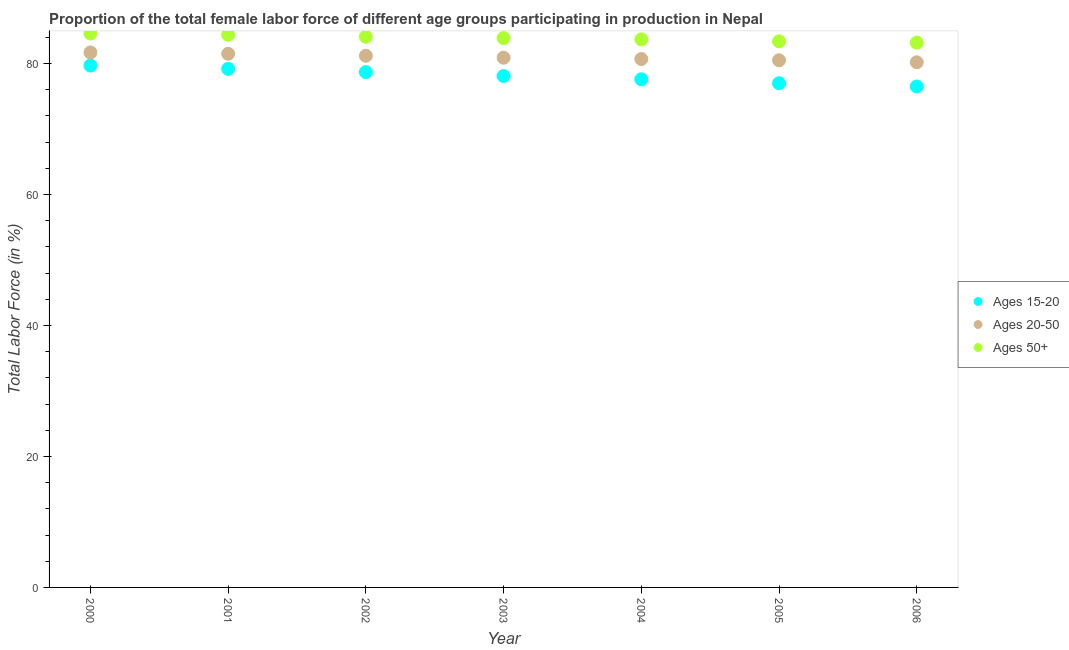Is the number of dotlines equal to the number of legend labels?
Your response must be concise. Yes. What is the percentage of female labor force above age 50 in 2004?
Provide a short and direct response. 83.7. Across all years, what is the maximum percentage of female labor force within the age group 20-50?
Give a very brief answer. 81.7. Across all years, what is the minimum percentage of female labor force within the age group 20-50?
Offer a very short reply. 80.2. In which year was the percentage of female labor force within the age group 15-20 maximum?
Your response must be concise. 2000. What is the total percentage of female labor force within the age group 15-20 in the graph?
Your answer should be compact. 546.8. What is the difference between the percentage of female labor force within the age group 15-20 in 2001 and the percentage of female labor force above age 50 in 2005?
Provide a short and direct response. -4.2. What is the average percentage of female labor force above age 50 per year?
Your answer should be compact. 83.9. In the year 2006, what is the difference between the percentage of female labor force within the age group 15-20 and percentage of female labor force within the age group 20-50?
Your answer should be compact. -3.7. What is the ratio of the percentage of female labor force within the age group 15-20 in 2003 to that in 2006?
Ensure brevity in your answer.  1.02. Is the percentage of female labor force above age 50 in 2001 less than that in 2004?
Provide a short and direct response. No. Is the difference between the percentage of female labor force within the age group 15-20 in 2004 and 2006 greater than the difference between the percentage of female labor force above age 50 in 2004 and 2006?
Provide a succinct answer. Yes. What is the difference between the highest and the second highest percentage of female labor force above age 50?
Your answer should be compact. 0.2. In how many years, is the percentage of female labor force within the age group 15-20 greater than the average percentage of female labor force within the age group 15-20 taken over all years?
Offer a very short reply. 3. Is the sum of the percentage of female labor force above age 50 in 2001 and 2004 greater than the maximum percentage of female labor force within the age group 20-50 across all years?
Provide a short and direct response. Yes. Is it the case that in every year, the sum of the percentage of female labor force within the age group 15-20 and percentage of female labor force within the age group 20-50 is greater than the percentage of female labor force above age 50?
Your response must be concise. Yes. Does the percentage of female labor force above age 50 monotonically increase over the years?
Make the answer very short. No. Is the percentage of female labor force within the age group 15-20 strictly greater than the percentage of female labor force above age 50 over the years?
Ensure brevity in your answer.  No. Is the percentage of female labor force above age 50 strictly less than the percentage of female labor force within the age group 20-50 over the years?
Make the answer very short. No. How many years are there in the graph?
Ensure brevity in your answer.  7. What is the difference between two consecutive major ticks on the Y-axis?
Offer a very short reply. 20. Are the values on the major ticks of Y-axis written in scientific E-notation?
Offer a terse response. No. Does the graph contain any zero values?
Give a very brief answer. No. Does the graph contain grids?
Make the answer very short. No. Where does the legend appear in the graph?
Make the answer very short. Center right. How many legend labels are there?
Keep it short and to the point. 3. How are the legend labels stacked?
Your answer should be very brief. Vertical. What is the title of the graph?
Keep it short and to the point. Proportion of the total female labor force of different age groups participating in production in Nepal. What is the label or title of the X-axis?
Your response must be concise. Year. What is the Total Labor Force (in %) of Ages 15-20 in 2000?
Make the answer very short. 79.7. What is the Total Labor Force (in %) of Ages 20-50 in 2000?
Provide a succinct answer. 81.7. What is the Total Labor Force (in %) of Ages 50+ in 2000?
Your answer should be compact. 84.6. What is the Total Labor Force (in %) of Ages 15-20 in 2001?
Offer a very short reply. 79.2. What is the Total Labor Force (in %) in Ages 20-50 in 2001?
Provide a succinct answer. 81.5. What is the Total Labor Force (in %) of Ages 50+ in 2001?
Your response must be concise. 84.4. What is the Total Labor Force (in %) of Ages 15-20 in 2002?
Your answer should be compact. 78.7. What is the Total Labor Force (in %) in Ages 20-50 in 2002?
Offer a terse response. 81.2. What is the Total Labor Force (in %) of Ages 50+ in 2002?
Make the answer very short. 84.1. What is the Total Labor Force (in %) of Ages 15-20 in 2003?
Provide a short and direct response. 78.1. What is the Total Labor Force (in %) in Ages 20-50 in 2003?
Provide a short and direct response. 80.9. What is the Total Labor Force (in %) of Ages 50+ in 2003?
Provide a succinct answer. 83.9. What is the Total Labor Force (in %) of Ages 15-20 in 2004?
Keep it short and to the point. 77.6. What is the Total Labor Force (in %) of Ages 20-50 in 2004?
Ensure brevity in your answer.  80.7. What is the Total Labor Force (in %) of Ages 50+ in 2004?
Give a very brief answer. 83.7. What is the Total Labor Force (in %) in Ages 20-50 in 2005?
Make the answer very short. 80.5. What is the Total Labor Force (in %) of Ages 50+ in 2005?
Your response must be concise. 83.4. What is the Total Labor Force (in %) in Ages 15-20 in 2006?
Your response must be concise. 76.5. What is the Total Labor Force (in %) in Ages 20-50 in 2006?
Your answer should be very brief. 80.2. What is the Total Labor Force (in %) of Ages 50+ in 2006?
Your answer should be very brief. 83.2. Across all years, what is the maximum Total Labor Force (in %) in Ages 15-20?
Your answer should be very brief. 79.7. Across all years, what is the maximum Total Labor Force (in %) of Ages 20-50?
Keep it short and to the point. 81.7. Across all years, what is the maximum Total Labor Force (in %) in Ages 50+?
Your response must be concise. 84.6. Across all years, what is the minimum Total Labor Force (in %) in Ages 15-20?
Offer a terse response. 76.5. Across all years, what is the minimum Total Labor Force (in %) in Ages 20-50?
Your answer should be very brief. 80.2. Across all years, what is the minimum Total Labor Force (in %) of Ages 50+?
Offer a very short reply. 83.2. What is the total Total Labor Force (in %) in Ages 15-20 in the graph?
Your answer should be very brief. 546.8. What is the total Total Labor Force (in %) of Ages 20-50 in the graph?
Provide a succinct answer. 566.7. What is the total Total Labor Force (in %) of Ages 50+ in the graph?
Keep it short and to the point. 587.3. What is the difference between the Total Labor Force (in %) in Ages 20-50 in 2000 and that in 2002?
Your answer should be very brief. 0.5. What is the difference between the Total Labor Force (in %) of Ages 50+ in 2000 and that in 2002?
Make the answer very short. 0.5. What is the difference between the Total Labor Force (in %) of Ages 15-20 in 2000 and that in 2003?
Your response must be concise. 1.6. What is the difference between the Total Labor Force (in %) of Ages 50+ in 2000 and that in 2003?
Your answer should be very brief. 0.7. What is the difference between the Total Labor Force (in %) in Ages 15-20 in 2000 and that in 2004?
Offer a terse response. 2.1. What is the difference between the Total Labor Force (in %) of Ages 20-50 in 2000 and that in 2004?
Provide a short and direct response. 1. What is the difference between the Total Labor Force (in %) in Ages 50+ in 2000 and that in 2004?
Keep it short and to the point. 0.9. What is the difference between the Total Labor Force (in %) of Ages 20-50 in 2000 and that in 2005?
Your answer should be very brief. 1.2. What is the difference between the Total Labor Force (in %) of Ages 15-20 in 2000 and that in 2006?
Keep it short and to the point. 3.2. What is the difference between the Total Labor Force (in %) of Ages 15-20 in 2001 and that in 2002?
Your response must be concise. 0.5. What is the difference between the Total Labor Force (in %) of Ages 50+ in 2001 and that in 2002?
Offer a very short reply. 0.3. What is the difference between the Total Labor Force (in %) in Ages 15-20 in 2001 and that in 2003?
Ensure brevity in your answer.  1.1. What is the difference between the Total Labor Force (in %) of Ages 50+ in 2001 and that in 2004?
Keep it short and to the point. 0.7. What is the difference between the Total Labor Force (in %) in Ages 20-50 in 2001 and that in 2005?
Make the answer very short. 1. What is the difference between the Total Labor Force (in %) of Ages 15-20 in 2001 and that in 2006?
Offer a very short reply. 2.7. What is the difference between the Total Labor Force (in %) of Ages 20-50 in 2001 and that in 2006?
Offer a very short reply. 1.3. What is the difference between the Total Labor Force (in %) of Ages 50+ in 2001 and that in 2006?
Give a very brief answer. 1.2. What is the difference between the Total Labor Force (in %) in Ages 20-50 in 2002 and that in 2005?
Your answer should be very brief. 0.7. What is the difference between the Total Labor Force (in %) of Ages 15-20 in 2002 and that in 2006?
Your response must be concise. 2.2. What is the difference between the Total Labor Force (in %) in Ages 20-50 in 2002 and that in 2006?
Keep it short and to the point. 1. What is the difference between the Total Labor Force (in %) in Ages 15-20 in 2003 and that in 2004?
Ensure brevity in your answer.  0.5. What is the difference between the Total Labor Force (in %) in Ages 20-50 in 2003 and that in 2004?
Provide a succinct answer. 0.2. What is the difference between the Total Labor Force (in %) in Ages 15-20 in 2003 and that in 2005?
Keep it short and to the point. 1.1. What is the difference between the Total Labor Force (in %) in Ages 15-20 in 2003 and that in 2006?
Your answer should be very brief. 1.6. What is the difference between the Total Labor Force (in %) in Ages 20-50 in 2003 and that in 2006?
Your answer should be compact. 0.7. What is the difference between the Total Labor Force (in %) of Ages 50+ in 2003 and that in 2006?
Provide a short and direct response. 0.7. What is the difference between the Total Labor Force (in %) of Ages 20-50 in 2004 and that in 2005?
Provide a short and direct response. 0.2. What is the difference between the Total Labor Force (in %) of Ages 15-20 in 2004 and that in 2006?
Your answer should be very brief. 1.1. What is the difference between the Total Labor Force (in %) in Ages 50+ in 2004 and that in 2006?
Ensure brevity in your answer.  0.5. What is the difference between the Total Labor Force (in %) of Ages 15-20 in 2005 and that in 2006?
Your response must be concise. 0.5. What is the difference between the Total Labor Force (in %) of Ages 50+ in 2005 and that in 2006?
Your answer should be very brief. 0.2. What is the difference between the Total Labor Force (in %) of Ages 15-20 in 2000 and the Total Labor Force (in %) of Ages 50+ in 2002?
Ensure brevity in your answer.  -4.4. What is the difference between the Total Labor Force (in %) in Ages 20-50 in 2000 and the Total Labor Force (in %) in Ages 50+ in 2002?
Your answer should be compact. -2.4. What is the difference between the Total Labor Force (in %) in Ages 15-20 in 2000 and the Total Labor Force (in %) in Ages 20-50 in 2003?
Make the answer very short. -1.2. What is the difference between the Total Labor Force (in %) of Ages 15-20 in 2000 and the Total Labor Force (in %) of Ages 50+ in 2003?
Give a very brief answer. -4.2. What is the difference between the Total Labor Force (in %) in Ages 20-50 in 2000 and the Total Labor Force (in %) in Ages 50+ in 2003?
Give a very brief answer. -2.2. What is the difference between the Total Labor Force (in %) in Ages 15-20 in 2000 and the Total Labor Force (in %) in Ages 20-50 in 2004?
Ensure brevity in your answer.  -1. What is the difference between the Total Labor Force (in %) in Ages 15-20 in 2000 and the Total Labor Force (in %) in Ages 20-50 in 2005?
Make the answer very short. -0.8. What is the difference between the Total Labor Force (in %) in Ages 15-20 in 2000 and the Total Labor Force (in %) in Ages 50+ in 2005?
Your answer should be very brief. -3.7. What is the difference between the Total Labor Force (in %) in Ages 15-20 in 2000 and the Total Labor Force (in %) in Ages 20-50 in 2006?
Provide a short and direct response. -0.5. What is the difference between the Total Labor Force (in %) in Ages 15-20 in 2001 and the Total Labor Force (in %) in Ages 20-50 in 2002?
Offer a terse response. -2. What is the difference between the Total Labor Force (in %) of Ages 20-50 in 2001 and the Total Labor Force (in %) of Ages 50+ in 2003?
Make the answer very short. -2.4. What is the difference between the Total Labor Force (in %) of Ages 15-20 in 2001 and the Total Labor Force (in %) of Ages 50+ in 2004?
Keep it short and to the point. -4.5. What is the difference between the Total Labor Force (in %) in Ages 20-50 in 2001 and the Total Labor Force (in %) in Ages 50+ in 2004?
Your response must be concise. -2.2. What is the difference between the Total Labor Force (in %) of Ages 15-20 in 2001 and the Total Labor Force (in %) of Ages 50+ in 2005?
Provide a succinct answer. -4.2. What is the difference between the Total Labor Force (in %) in Ages 15-20 in 2001 and the Total Labor Force (in %) in Ages 20-50 in 2006?
Offer a very short reply. -1. What is the difference between the Total Labor Force (in %) of Ages 20-50 in 2001 and the Total Labor Force (in %) of Ages 50+ in 2006?
Provide a short and direct response. -1.7. What is the difference between the Total Labor Force (in %) in Ages 15-20 in 2002 and the Total Labor Force (in %) in Ages 50+ in 2003?
Your answer should be very brief. -5.2. What is the difference between the Total Labor Force (in %) in Ages 20-50 in 2002 and the Total Labor Force (in %) in Ages 50+ in 2003?
Make the answer very short. -2.7. What is the difference between the Total Labor Force (in %) in Ages 15-20 in 2002 and the Total Labor Force (in %) in Ages 20-50 in 2004?
Make the answer very short. -2. What is the difference between the Total Labor Force (in %) of Ages 15-20 in 2002 and the Total Labor Force (in %) of Ages 20-50 in 2005?
Keep it short and to the point. -1.8. What is the difference between the Total Labor Force (in %) of Ages 15-20 in 2002 and the Total Labor Force (in %) of Ages 50+ in 2005?
Give a very brief answer. -4.7. What is the difference between the Total Labor Force (in %) in Ages 15-20 in 2002 and the Total Labor Force (in %) in Ages 20-50 in 2006?
Provide a succinct answer. -1.5. What is the difference between the Total Labor Force (in %) in Ages 15-20 in 2003 and the Total Labor Force (in %) in Ages 50+ in 2004?
Give a very brief answer. -5.6. What is the difference between the Total Labor Force (in %) in Ages 15-20 in 2003 and the Total Labor Force (in %) in Ages 20-50 in 2005?
Give a very brief answer. -2.4. What is the difference between the Total Labor Force (in %) in Ages 20-50 in 2003 and the Total Labor Force (in %) in Ages 50+ in 2005?
Your answer should be compact. -2.5. What is the difference between the Total Labor Force (in %) of Ages 15-20 in 2004 and the Total Labor Force (in %) of Ages 50+ in 2006?
Your answer should be very brief. -5.6. What is the average Total Labor Force (in %) in Ages 15-20 per year?
Give a very brief answer. 78.11. What is the average Total Labor Force (in %) of Ages 20-50 per year?
Make the answer very short. 80.96. What is the average Total Labor Force (in %) in Ages 50+ per year?
Offer a terse response. 83.9. In the year 2000, what is the difference between the Total Labor Force (in %) in Ages 15-20 and Total Labor Force (in %) in Ages 20-50?
Provide a succinct answer. -2. In the year 2000, what is the difference between the Total Labor Force (in %) of Ages 15-20 and Total Labor Force (in %) of Ages 50+?
Make the answer very short. -4.9. In the year 2001, what is the difference between the Total Labor Force (in %) of Ages 15-20 and Total Labor Force (in %) of Ages 20-50?
Keep it short and to the point. -2.3. In the year 2001, what is the difference between the Total Labor Force (in %) in Ages 15-20 and Total Labor Force (in %) in Ages 50+?
Give a very brief answer. -5.2. In the year 2002, what is the difference between the Total Labor Force (in %) of Ages 15-20 and Total Labor Force (in %) of Ages 50+?
Offer a very short reply. -5.4. In the year 2002, what is the difference between the Total Labor Force (in %) in Ages 20-50 and Total Labor Force (in %) in Ages 50+?
Keep it short and to the point. -2.9. In the year 2003, what is the difference between the Total Labor Force (in %) of Ages 15-20 and Total Labor Force (in %) of Ages 20-50?
Your answer should be very brief. -2.8. In the year 2004, what is the difference between the Total Labor Force (in %) of Ages 15-20 and Total Labor Force (in %) of Ages 50+?
Provide a succinct answer. -6.1. In the year 2004, what is the difference between the Total Labor Force (in %) of Ages 20-50 and Total Labor Force (in %) of Ages 50+?
Provide a short and direct response. -3. In the year 2005, what is the difference between the Total Labor Force (in %) of Ages 20-50 and Total Labor Force (in %) of Ages 50+?
Make the answer very short. -2.9. In the year 2006, what is the difference between the Total Labor Force (in %) in Ages 20-50 and Total Labor Force (in %) in Ages 50+?
Your answer should be very brief. -3. What is the ratio of the Total Labor Force (in %) in Ages 15-20 in 2000 to that in 2001?
Give a very brief answer. 1.01. What is the ratio of the Total Labor Force (in %) in Ages 15-20 in 2000 to that in 2002?
Your answer should be very brief. 1.01. What is the ratio of the Total Labor Force (in %) of Ages 50+ in 2000 to that in 2002?
Your response must be concise. 1.01. What is the ratio of the Total Labor Force (in %) in Ages 15-20 in 2000 to that in 2003?
Keep it short and to the point. 1.02. What is the ratio of the Total Labor Force (in %) in Ages 20-50 in 2000 to that in 2003?
Your answer should be very brief. 1.01. What is the ratio of the Total Labor Force (in %) of Ages 50+ in 2000 to that in 2003?
Provide a short and direct response. 1.01. What is the ratio of the Total Labor Force (in %) in Ages 15-20 in 2000 to that in 2004?
Your answer should be very brief. 1.03. What is the ratio of the Total Labor Force (in %) in Ages 20-50 in 2000 to that in 2004?
Your response must be concise. 1.01. What is the ratio of the Total Labor Force (in %) of Ages 50+ in 2000 to that in 2004?
Your answer should be very brief. 1.01. What is the ratio of the Total Labor Force (in %) of Ages 15-20 in 2000 to that in 2005?
Your answer should be very brief. 1.04. What is the ratio of the Total Labor Force (in %) in Ages 20-50 in 2000 to that in 2005?
Offer a terse response. 1.01. What is the ratio of the Total Labor Force (in %) of Ages 50+ in 2000 to that in 2005?
Offer a terse response. 1.01. What is the ratio of the Total Labor Force (in %) of Ages 15-20 in 2000 to that in 2006?
Offer a very short reply. 1.04. What is the ratio of the Total Labor Force (in %) in Ages 20-50 in 2000 to that in 2006?
Keep it short and to the point. 1.02. What is the ratio of the Total Labor Force (in %) of Ages 50+ in 2000 to that in 2006?
Make the answer very short. 1.02. What is the ratio of the Total Labor Force (in %) of Ages 15-20 in 2001 to that in 2002?
Offer a terse response. 1.01. What is the ratio of the Total Labor Force (in %) in Ages 15-20 in 2001 to that in 2003?
Your response must be concise. 1.01. What is the ratio of the Total Labor Force (in %) in Ages 20-50 in 2001 to that in 2003?
Your response must be concise. 1.01. What is the ratio of the Total Labor Force (in %) of Ages 15-20 in 2001 to that in 2004?
Ensure brevity in your answer.  1.02. What is the ratio of the Total Labor Force (in %) of Ages 20-50 in 2001 to that in 2004?
Your response must be concise. 1.01. What is the ratio of the Total Labor Force (in %) in Ages 50+ in 2001 to that in 2004?
Provide a short and direct response. 1.01. What is the ratio of the Total Labor Force (in %) of Ages 15-20 in 2001 to that in 2005?
Your answer should be very brief. 1.03. What is the ratio of the Total Labor Force (in %) of Ages 20-50 in 2001 to that in 2005?
Your response must be concise. 1.01. What is the ratio of the Total Labor Force (in %) of Ages 15-20 in 2001 to that in 2006?
Your answer should be compact. 1.04. What is the ratio of the Total Labor Force (in %) in Ages 20-50 in 2001 to that in 2006?
Your response must be concise. 1.02. What is the ratio of the Total Labor Force (in %) of Ages 50+ in 2001 to that in 2006?
Provide a short and direct response. 1.01. What is the ratio of the Total Labor Force (in %) in Ages 15-20 in 2002 to that in 2003?
Provide a succinct answer. 1.01. What is the ratio of the Total Labor Force (in %) in Ages 50+ in 2002 to that in 2003?
Your response must be concise. 1. What is the ratio of the Total Labor Force (in %) of Ages 15-20 in 2002 to that in 2004?
Provide a short and direct response. 1.01. What is the ratio of the Total Labor Force (in %) in Ages 50+ in 2002 to that in 2004?
Provide a short and direct response. 1. What is the ratio of the Total Labor Force (in %) of Ages 15-20 in 2002 to that in 2005?
Make the answer very short. 1.02. What is the ratio of the Total Labor Force (in %) in Ages 20-50 in 2002 to that in 2005?
Provide a short and direct response. 1.01. What is the ratio of the Total Labor Force (in %) of Ages 50+ in 2002 to that in 2005?
Give a very brief answer. 1.01. What is the ratio of the Total Labor Force (in %) in Ages 15-20 in 2002 to that in 2006?
Make the answer very short. 1.03. What is the ratio of the Total Labor Force (in %) in Ages 20-50 in 2002 to that in 2006?
Offer a terse response. 1.01. What is the ratio of the Total Labor Force (in %) in Ages 50+ in 2002 to that in 2006?
Offer a very short reply. 1.01. What is the ratio of the Total Labor Force (in %) in Ages 15-20 in 2003 to that in 2004?
Make the answer very short. 1.01. What is the ratio of the Total Labor Force (in %) in Ages 20-50 in 2003 to that in 2004?
Give a very brief answer. 1. What is the ratio of the Total Labor Force (in %) in Ages 50+ in 2003 to that in 2004?
Provide a short and direct response. 1. What is the ratio of the Total Labor Force (in %) of Ages 15-20 in 2003 to that in 2005?
Offer a terse response. 1.01. What is the ratio of the Total Labor Force (in %) of Ages 20-50 in 2003 to that in 2005?
Offer a very short reply. 1. What is the ratio of the Total Labor Force (in %) in Ages 15-20 in 2003 to that in 2006?
Your answer should be very brief. 1.02. What is the ratio of the Total Labor Force (in %) of Ages 20-50 in 2003 to that in 2006?
Make the answer very short. 1.01. What is the ratio of the Total Labor Force (in %) of Ages 50+ in 2003 to that in 2006?
Your response must be concise. 1.01. What is the ratio of the Total Labor Force (in %) of Ages 15-20 in 2004 to that in 2005?
Provide a succinct answer. 1.01. What is the ratio of the Total Labor Force (in %) of Ages 15-20 in 2004 to that in 2006?
Keep it short and to the point. 1.01. What is the ratio of the Total Labor Force (in %) of Ages 20-50 in 2005 to that in 2006?
Offer a terse response. 1. What is the ratio of the Total Labor Force (in %) of Ages 50+ in 2005 to that in 2006?
Make the answer very short. 1. What is the difference between the highest and the second highest Total Labor Force (in %) of Ages 15-20?
Keep it short and to the point. 0.5. What is the difference between the highest and the second highest Total Labor Force (in %) in Ages 50+?
Make the answer very short. 0.2. What is the difference between the highest and the lowest Total Labor Force (in %) of Ages 15-20?
Provide a short and direct response. 3.2. 